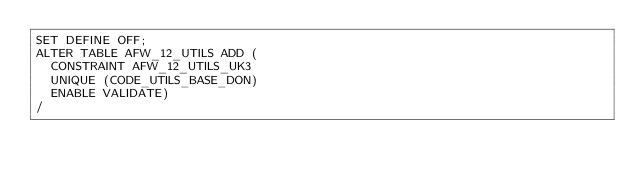<code> <loc_0><loc_0><loc_500><loc_500><_SQL_>SET DEFINE OFF;
ALTER TABLE AFW_12_UTILS ADD (
  CONSTRAINT AFW_12_UTILS_UK3
  UNIQUE (CODE_UTILS_BASE_DON)
  ENABLE VALIDATE)
/
</code> 